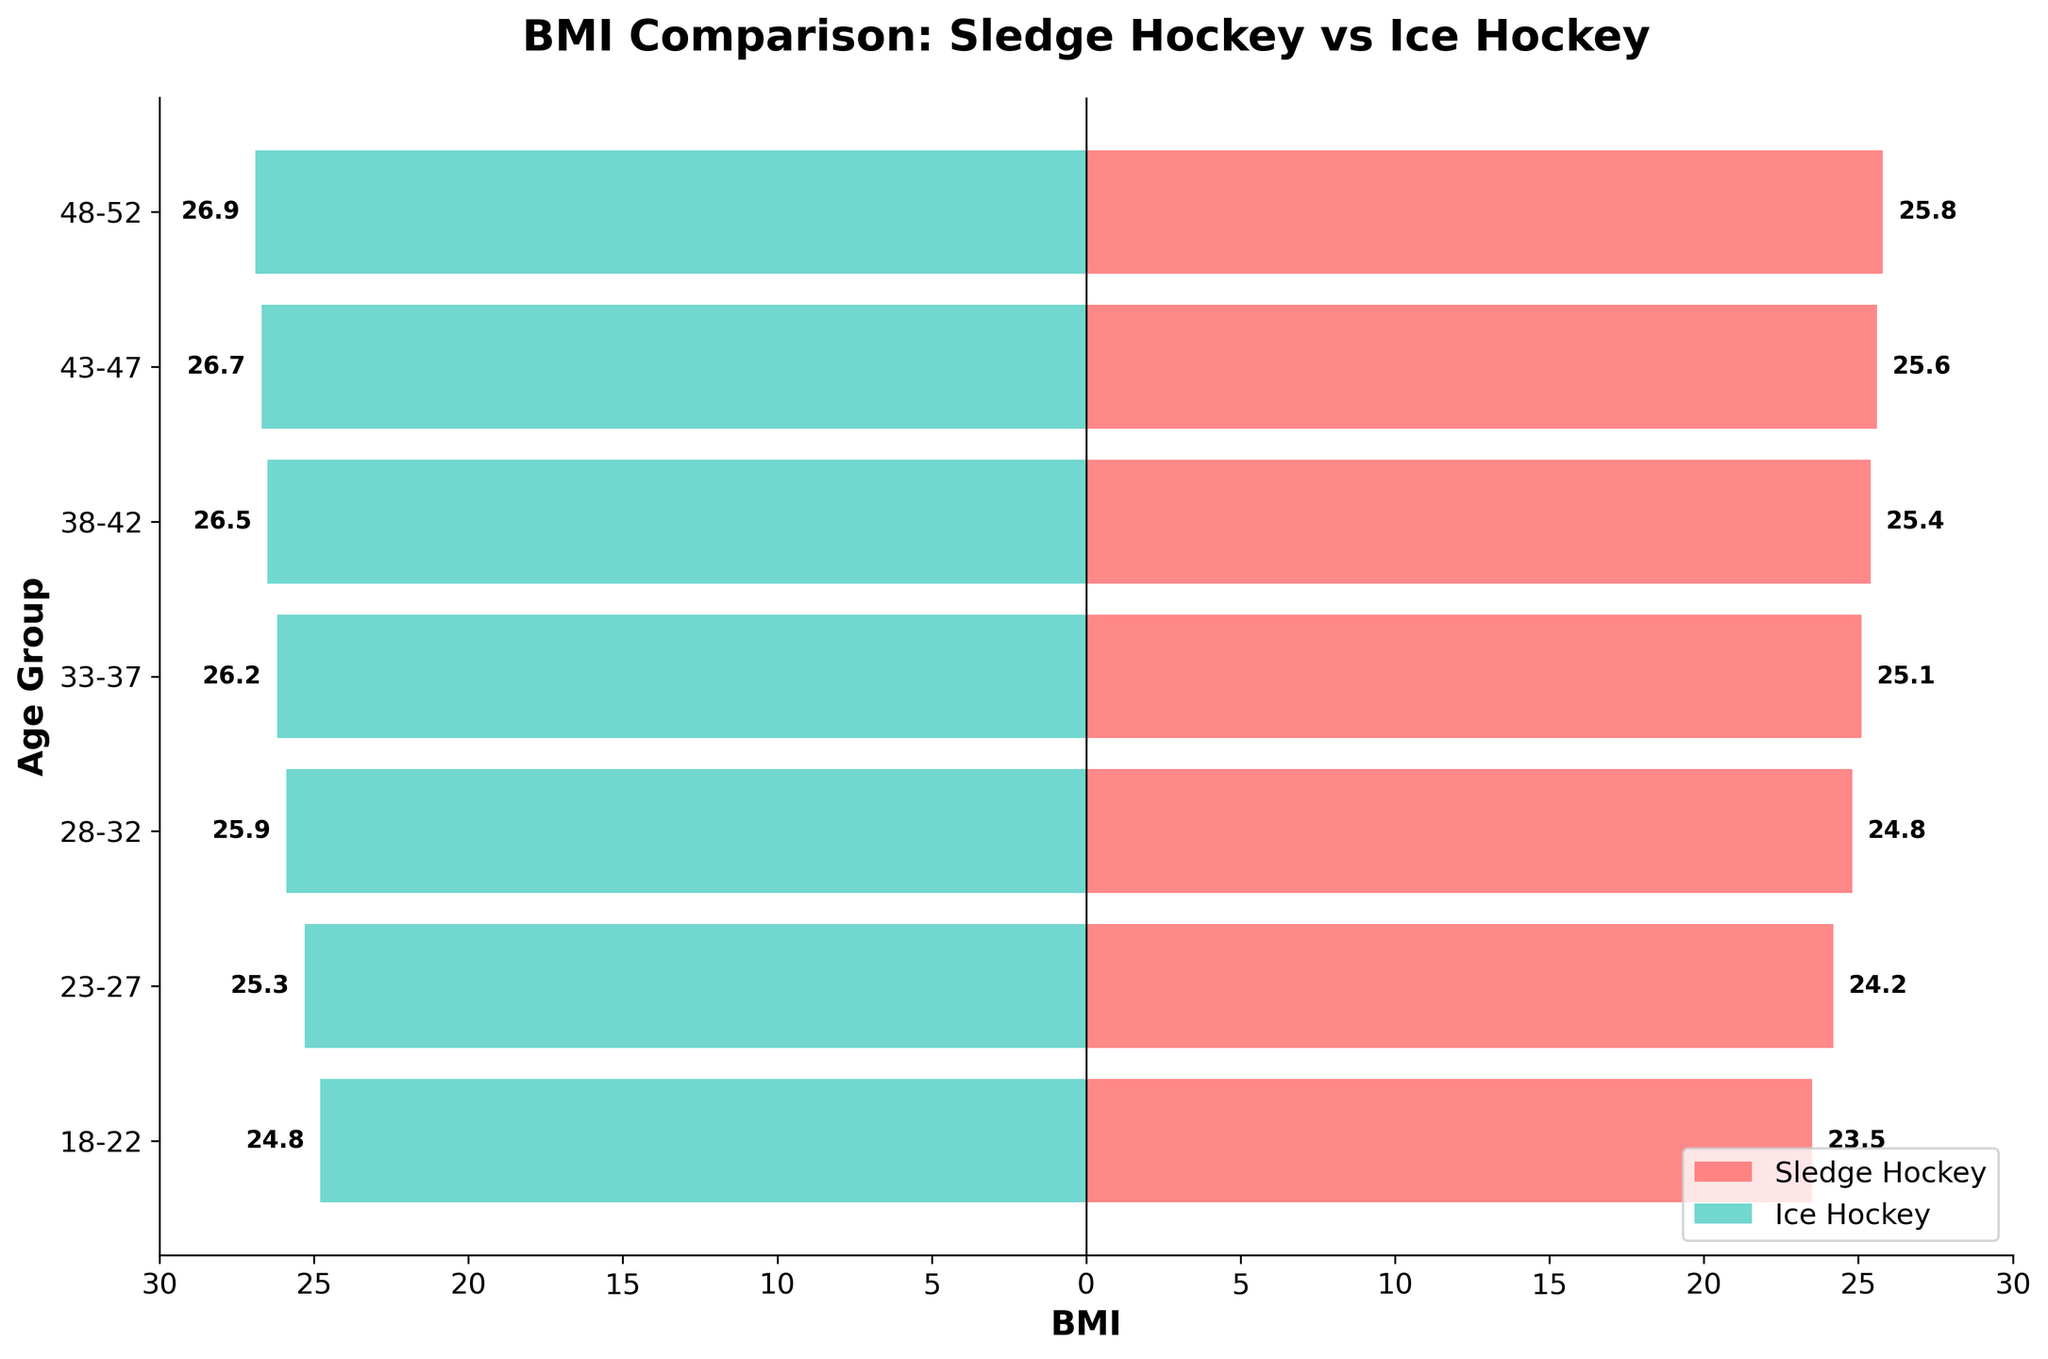How many age groups are compared in the figure? The figure shows bars for different age groups on the y-axis. By counting these bars, we see there are seven age groups displayed.
Answer: 7 What are the BMI ranges for sledge hockey players and ice hockey players in the figure? The BMI for sledge hockey players ranges from 23.5 to 25.8, and for ice hockey players, it ranges from 24.8 to 26.9, as depicted by the values of the horizontal bars.
Answer: Sledge Hockey: 23.5 - 25.8, Ice Hockey: 24.8 - 26.9 In which age group do both sledge hockey and ice hockey players have the smallest BMI difference? To determine this, calculate the differences between BMI values for each age group. The smallest difference occurs in the 18-22 age group, with a difference of 1.3 (24.8 - 23.5).
Answer: 18-22 What is the BMI of sledge hockey players aged 28-32? Look at the horizontal bar corresponding to the "28-32" age group on the left side of the figure. The BMI value next to this bar is 24.8.
Answer: 24.8 Do ice hockey players generally have a higher BMI than sledge hockey players? By visually comparing the lengths of the horizontal bars, we observe that the bars on the right (ice hockey) typically extend further than those on the left (sledge hockey). Hence, ice hockey players generally have a higher BMI.
Answer: Yes How much higher is the average BMI of ice hockey players compared to sledge hockey players? First, calculate the average BMI for both groups. Sledge Hockey: (23.5 + 24.2 + 24.8 + 25.1 + 25.4 + 25.6 + 25.8) / 7 = 24.91. Ice Hockey: (24.8 + 25.3 + 25.9 + 26.2 + 26.5 + 26.7 + 26.9) / 7 = 26.04. The difference is 26.04 - 24.91 = 1.13.
Answer: 1.13 Which age group has the highest BMI for ice hockey players? Observing the horizontal bars on the right side of the figure, the age group "48-52" has the tallest bar indicating a BMI of 26.9.
Answer: 48-52 Is there an increasing trend in BMI for both sledge and ice hockey players across older age groups? By analyzing the lengths of the bars from left to right, we see an uptrend in BMI values for both sledge and ice hockey players as age increases.
Answer: Yes Which age group has the smallest BMI for sledge hockey players? The shortest bar on the left side of the figure corresponds to the "18-22" age group, with a BMI of 23.5.
Answer: 18-22 